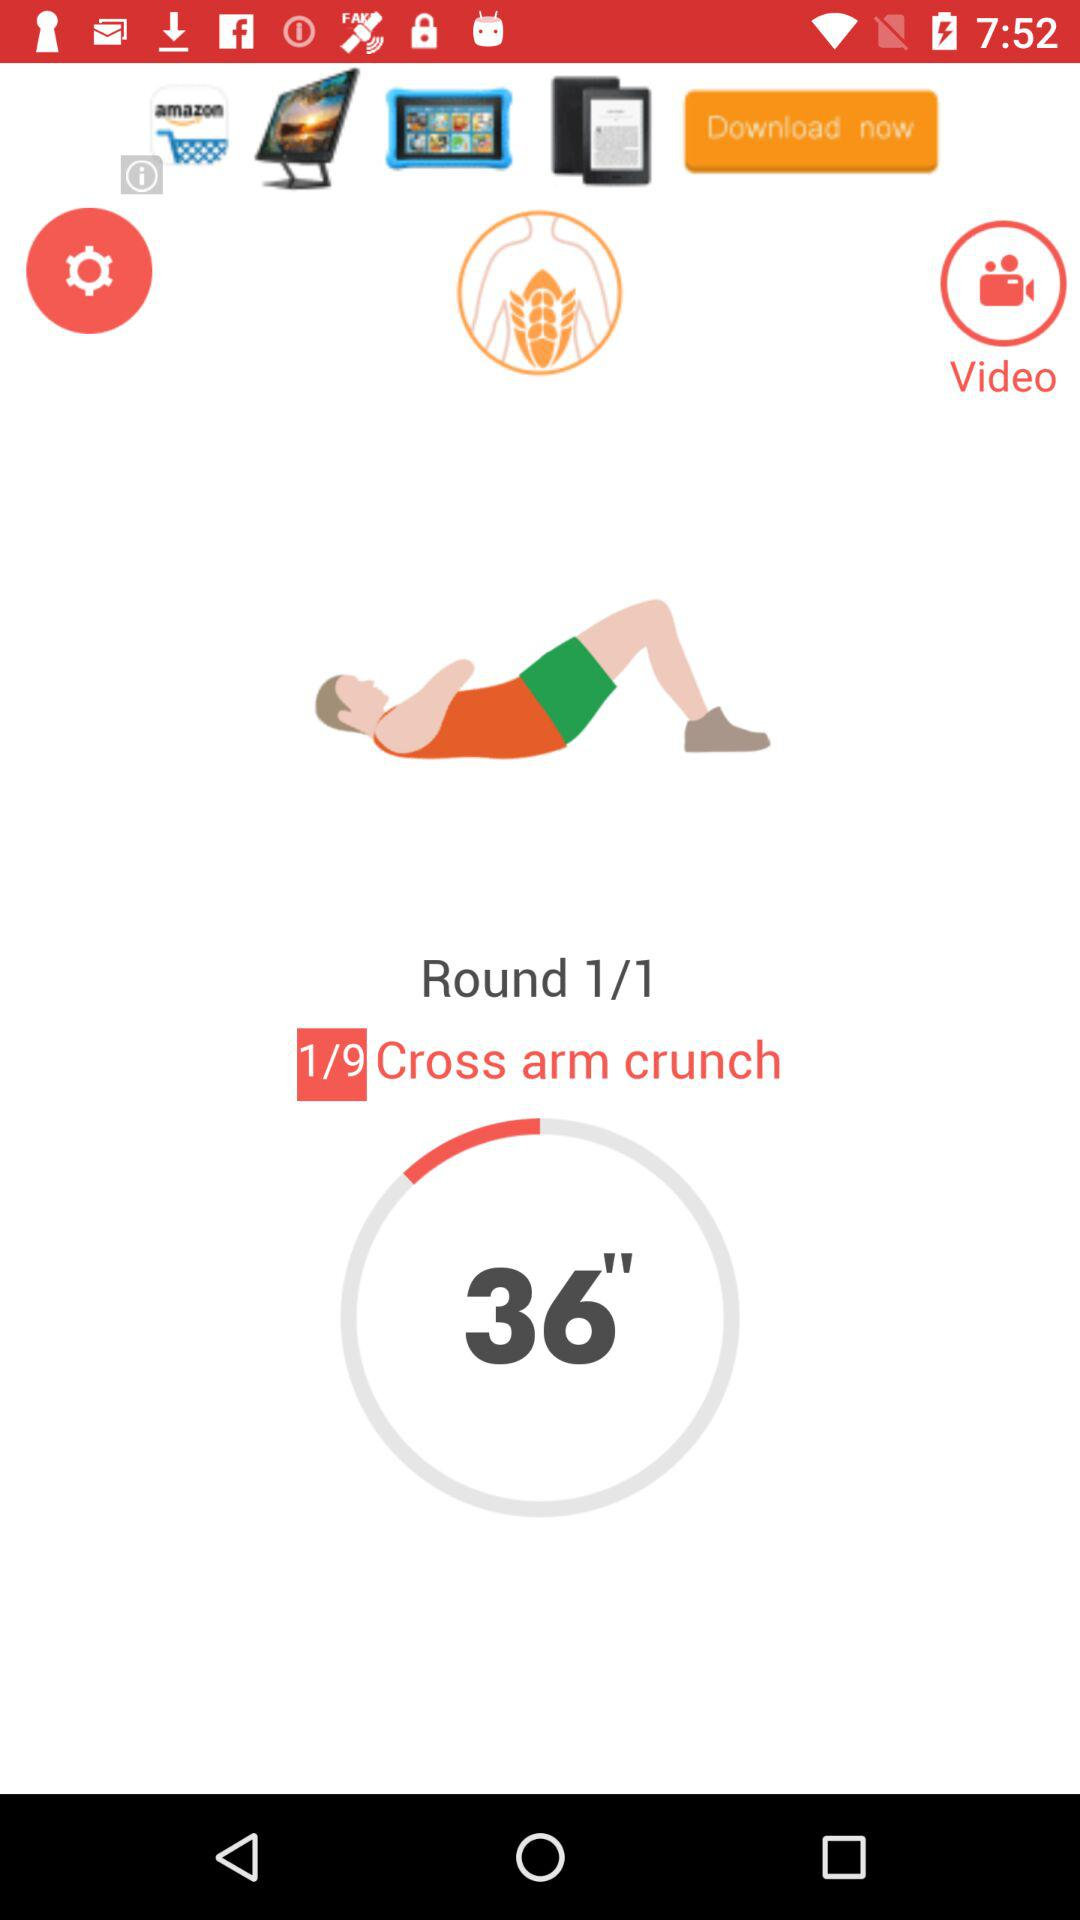How many rounds are there? There is 1 round. 